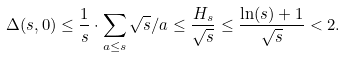<formula> <loc_0><loc_0><loc_500><loc_500>\Delta ( s , 0 ) \leq \frac { 1 } { s } \cdot \sum _ { a \leq s } \sqrt { s } / a \leq \frac { H _ { s } } { \sqrt { s } } \leq \frac { \ln ( s ) + 1 } { \sqrt { s } } < 2 .</formula> 